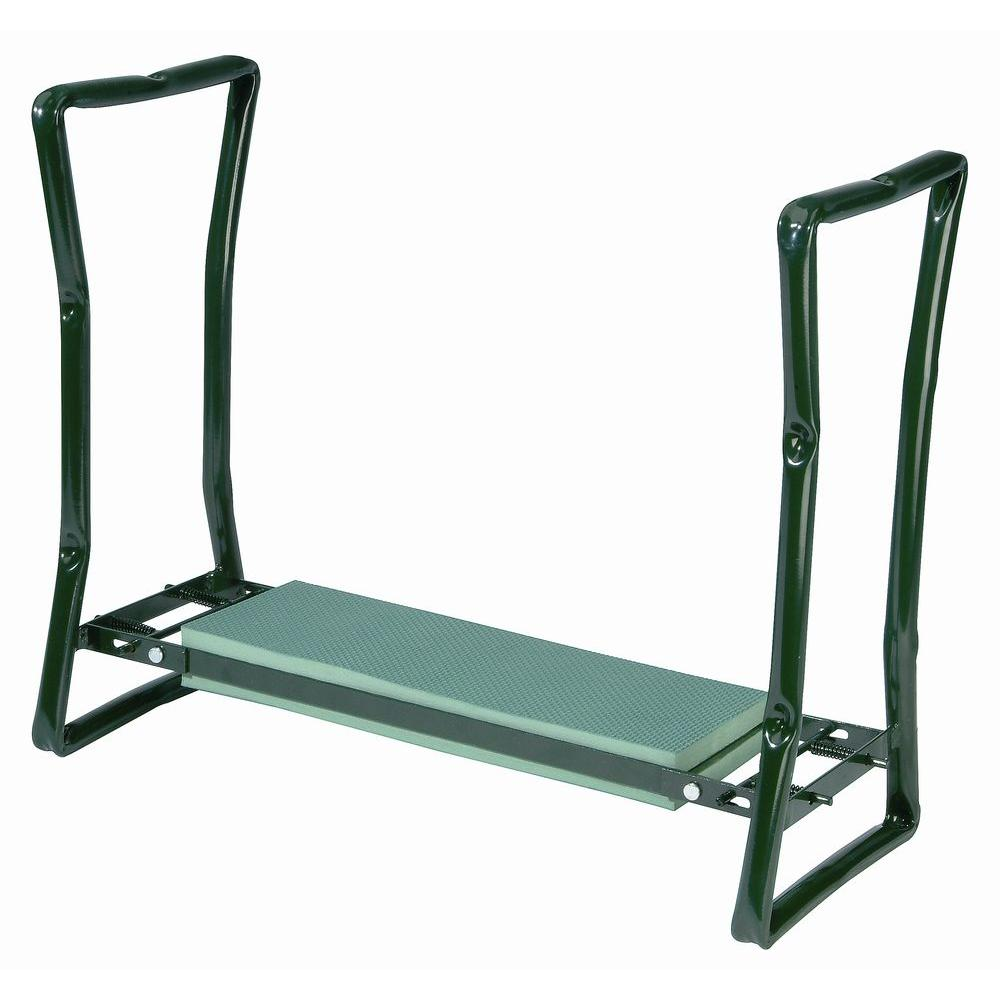Considering the design and features of this squat stand, what kind of weight range do you think it is built to support, and why? The squat stand in the image is constructed with a durable metal framework and a series of adjustment holes along the uprights, suggesting it is engineered for high-load capacity. The design includes reinforced joints and a substantial lower crossbar to distribute the weight of a barbell effectively. Structurally, the presence of the middle crossbar adds stability, reducing the risk of bending under heavy weights. While the exact weight it can handle would depend on the type of metal used and the precision of the engineering, it's reasonable to estimate it could support between 500 to 1200 pounds, catering to both amateur and seasoned lifters. For precise load specifications, one would typically refer to manufacturer guidelines or seek insights from structural engineering evaluations specific to this model. 